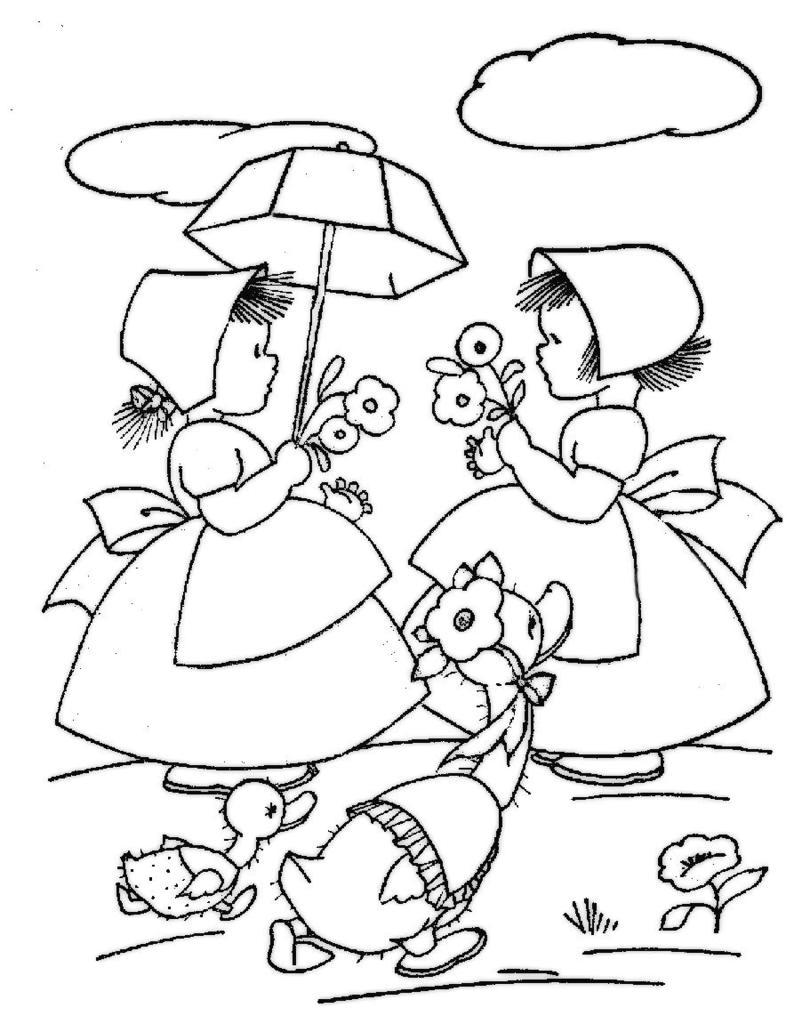What is the main subject of the image? The image contains an art piece. What is depicted in the art piece? The art piece depicts persons and birds. Reasoning: Let' Let's think step by step in order to produce the conversation. We start by identifying the main subject of the image, which is the art piece. Then, we describe what is depicted in the art piece, mentioning both the persons and the birds. We avoid making assumptions about the image or asking questions that cannot be answered definitively based on the provided facts. Absurd Question/Answer: What type of toy can be seen being shaken by a person in the image? There is no toy or person shaking a toy present in the image; it features an art piece depicting persons and birds. What type of park can be seen in the background of the image? There is no park present in the image; it features an art piece depicting persons and birds. 